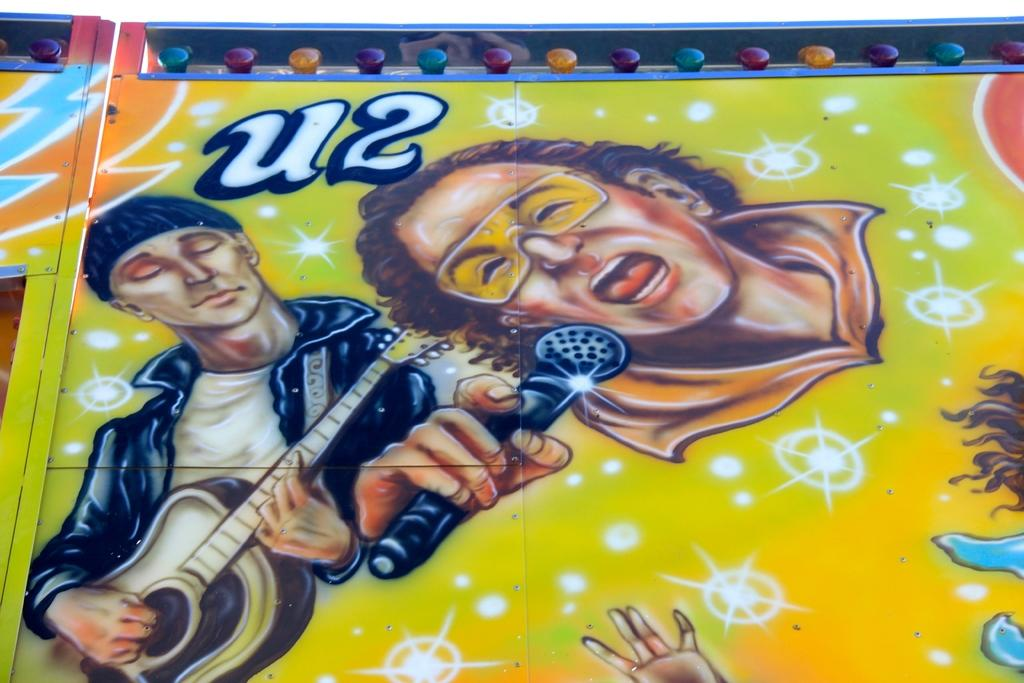What is the main subject of the image? The main subject of the image is an object with painting. What additional feature can be seen on the object? There are colorful lights attached to the object. What type of chess piece is depicted in the painting on the object? There is no chess piece visible in the painting on the object. What type of educational material is present in the image? There is no educational material present in the image; it features an object with painting and colorful lights. 